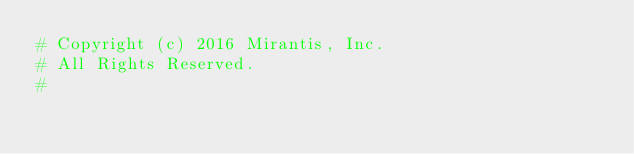Convert code to text. <code><loc_0><loc_0><loc_500><loc_500><_Python_># Copyright (c) 2016 Mirantis, Inc.
# All Rights Reserved.
#</code> 